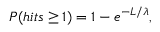<formula> <loc_0><loc_0><loc_500><loc_500>P ( h i t s \geq 1 ) = 1 - e ^ { - L / \lambda } ,</formula> 